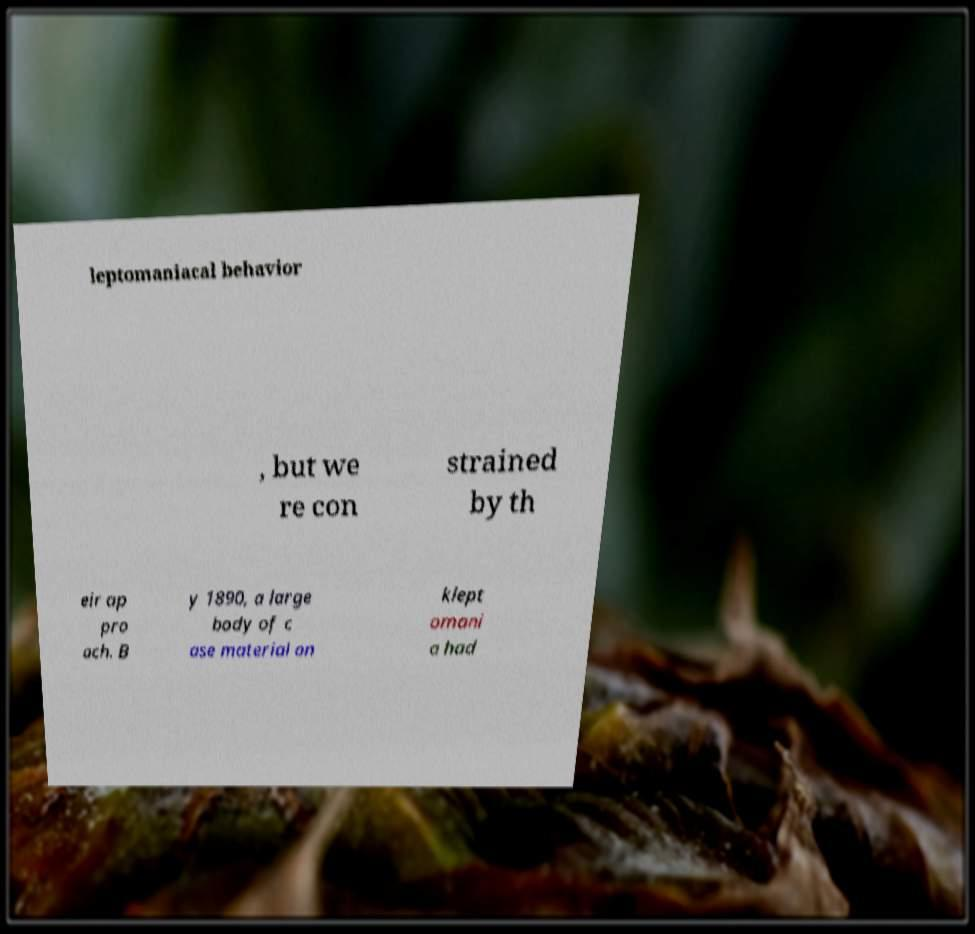What messages or text are displayed in this image? I need them in a readable, typed format. leptomaniacal behavior , but we re con strained by th eir ap pro ach. B y 1890, a large body of c ase material on klept omani a had 